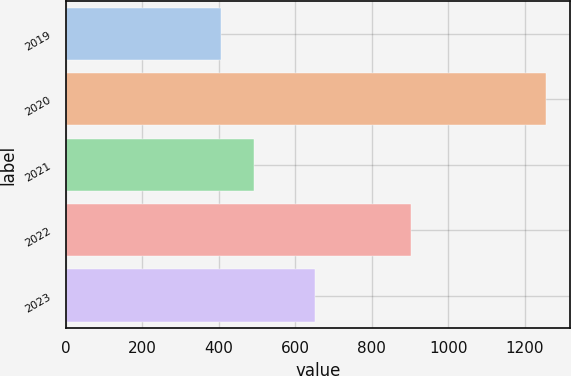<chart> <loc_0><loc_0><loc_500><loc_500><bar_chart><fcel>2019<fcel>2020<fcel>2021<fcel>2022<fcel>2023<nl><fcel>406<fcel>1257<fcel>491.1<fcel>902<fcel>653<nl></chart> 